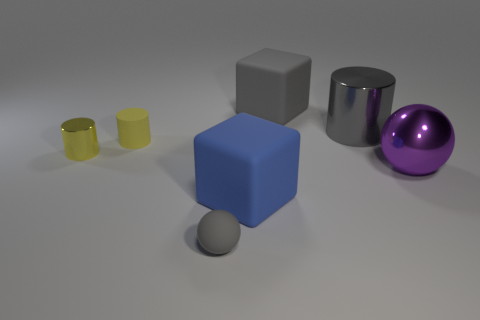Add 1 tiny blue metal cylinders. How many objects exist? 8 Subtract all spheres. How many objects are left? 5 Subtract all small gray cubes. Subtract all tiny spheres. How many objects are left? 6 Add 3 tiny yellow metal objects. How many tiny yellow metal objects are left? 4 Add 6 yellow shiny cylinders. How many yellow shiny cylinders exist? 7 Subtract 0 green cylinders. How many objects are left? 7 